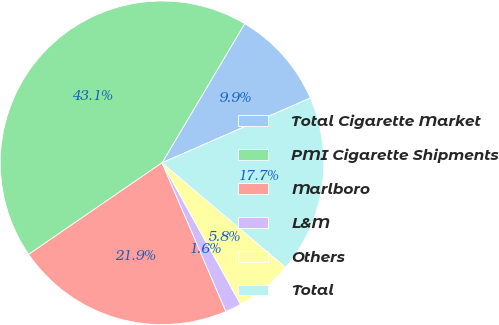Convert chart to OTSL. <chart><loc_0><loc_0><loc_500><loc_500><pie_chart><fcel>Total Cigarette Market<fcel>PMI Cigarette Shipments<fcel>Marlboro<fcel>L&M<fcel>Others<fcel>Total<nl><fcel>9.91%<fcel>43.11%<fcel>21.88%<fcel>1.61%<fcel>5.76%<fcel>17.73%<nl></chart> 